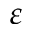<formula> <loc_0><loc_0><loc_500><loc_500>\varepsilon</formula> 